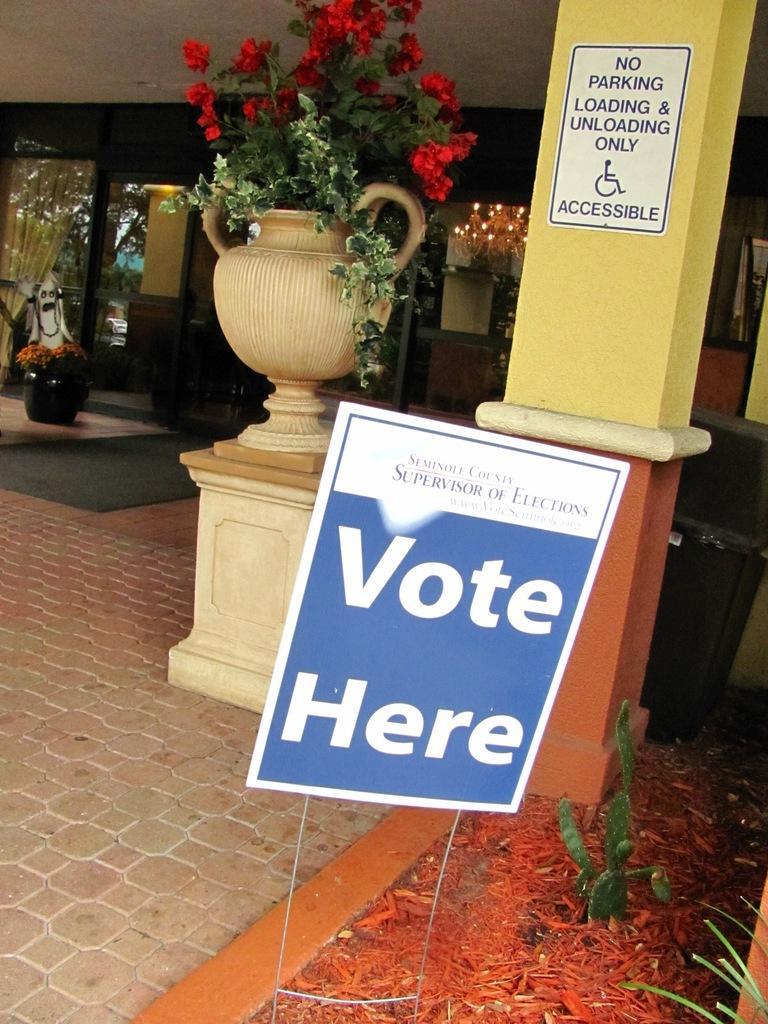Could you give a brief overview of what you see in this image? In this image, we can see flower pots, some lights, poles and here we can see posters. On the bottom right, there is a plant. 